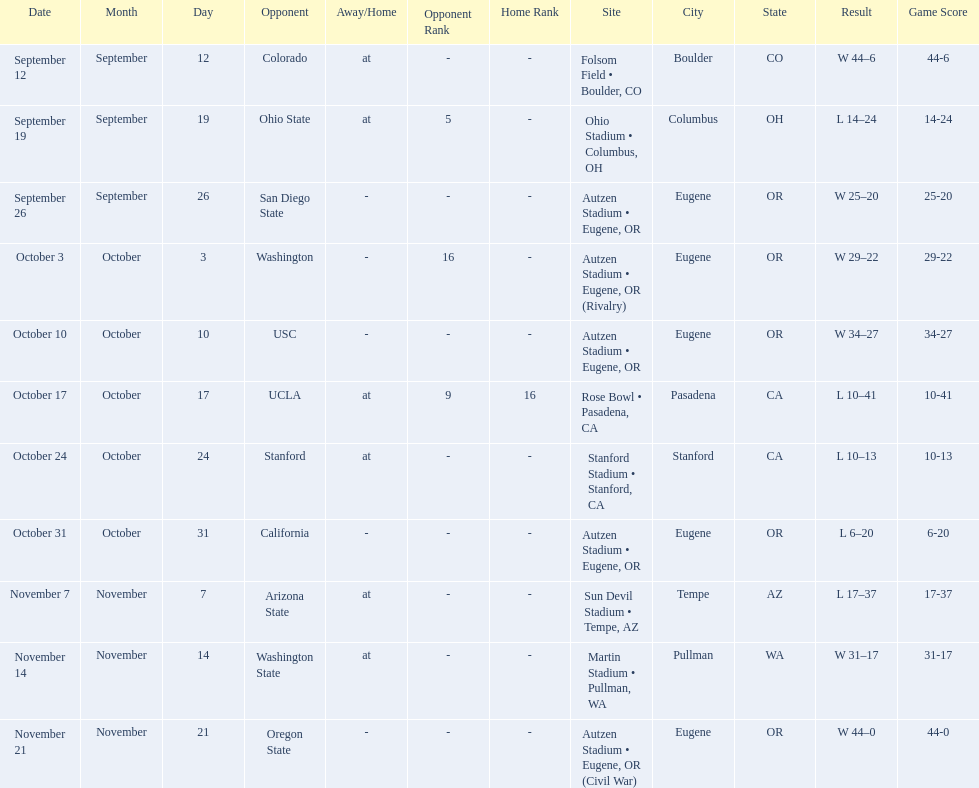What is the number of away games ? 6. 